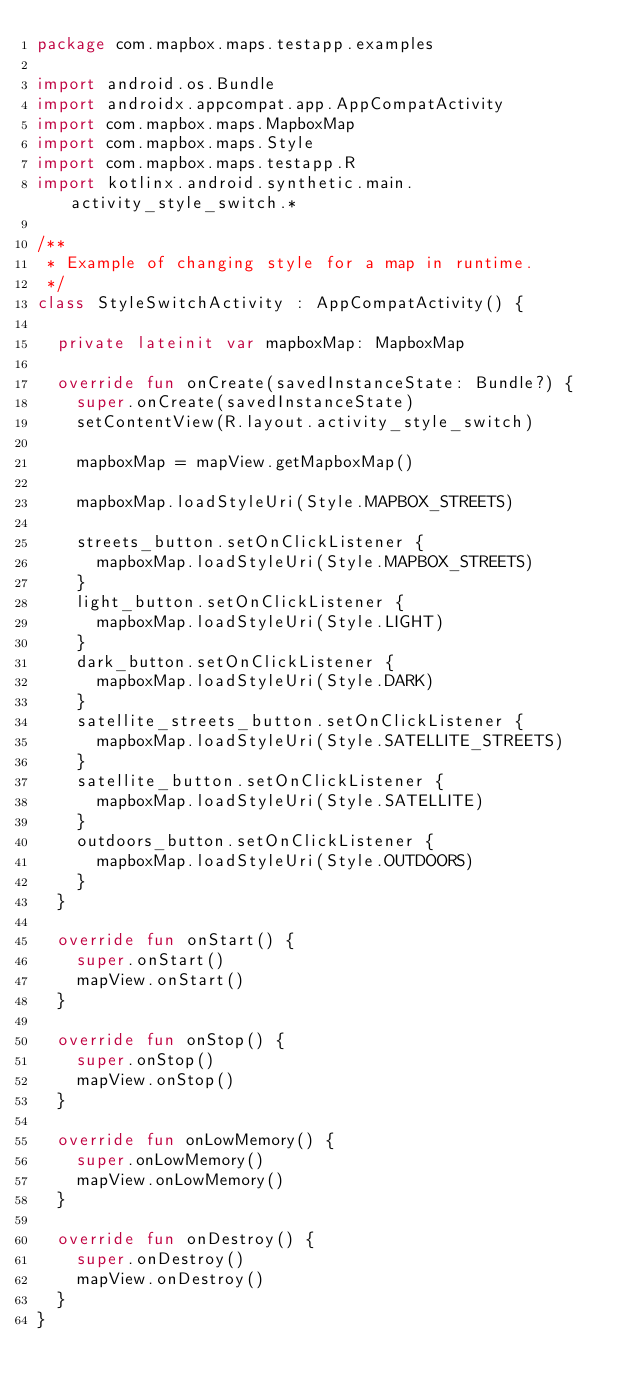<code> <loc_0><loc_0><loc_500><loc_500><_Kotlin_>package com.mapbox.maps.testapp.examples

import android.os.Bundle
import androidx.appcompat.app.AppCompatActivity
import com.mapbox.maps.MapboxMap
import com.mapbox.maps.Style
import com.mapbox.maps.testapp.R
import kotlinx.android.synthetic.main.activity_style_switch.*

/**
 * Example of changing style for a map in runtime.
 */
class StyleSwitchActivity : AppCompatActivity() {

  private lateinit var mapboxMap: MapboxMap

  override fun onCreate(savedInstanceState: Bundle?) {
    super.onCreate(savedInstanceState)
    setContentView(R.layout.activity_style_switch)

    mapboxMap = mapView.getMapboxMap()

    mapboxMap.loadStyleUri(Style.MAPBOX_STREETS)

    streets_button.setOnClickListener {
      mapboxMap.loadStyleUri(Style.MAPBOX_STREETS)
    }
    light_button.setOnClickListener {
      mapboxMap.loadStyleUri(Style.LIGHT)
    }
    dark_button.setOnClickListener {
      mapboxMap.loadStyleUri(Style.DARK)
    }
    satellite_streets_button.setOnClickListener {
      mapboxMap.loadStyleUri(Style.SATELLITE_STREETS)
    }
    satellite_button.setOnClickListener {
      mapboxMap.loadStyleUri(Style.SATELLITE)
    }
    outdoors_button.setOnClickListener {
      mapboxMap.loadStyleUri(Style.OUTDOORS)
    }
  }

  override fun onStart() {
    super.onStart()
    mapView.onStart()
  }

  override fun onStop() {
    super.onStop()
    mapView.onStop()
  }

  override fun onLowMemory() {
    super.onLowMemory()
    mapView.onLowMemory()
  }

  override fun onDestroy() {
    super.onDestroy()
    mapView.onDestroy()
  }
}</code> 